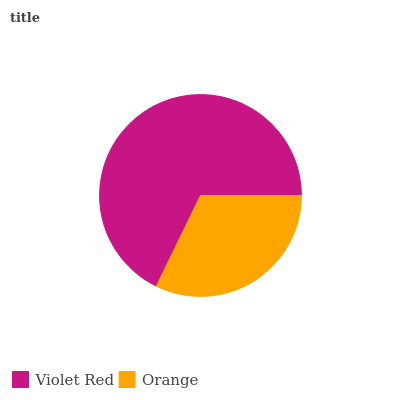Is Orange the minimum?
Answer yes or no. Yes. Is Violet Red the maximum?
Answer yes or no. Yes. Is Orange the maximum?
Answer yes or no. No. Is Violet Red greater than Orange?
Answer yes or no. Yes. Is Orange less than Violet Red?
Answer yes or no. Yes. Is Orange greater than Violet Red?
Answer yes or no. No. Is Violet Red less than Orange?
Answer yes or no. No. Is Violet Red the high median?
Answer yes or no. Yes. Is Orange the low median?
Answer yes or no. Yes. Is Orange the high median?
Answer yes or no. No. Is Violet Red the low median?
Answer yes or no. No. 